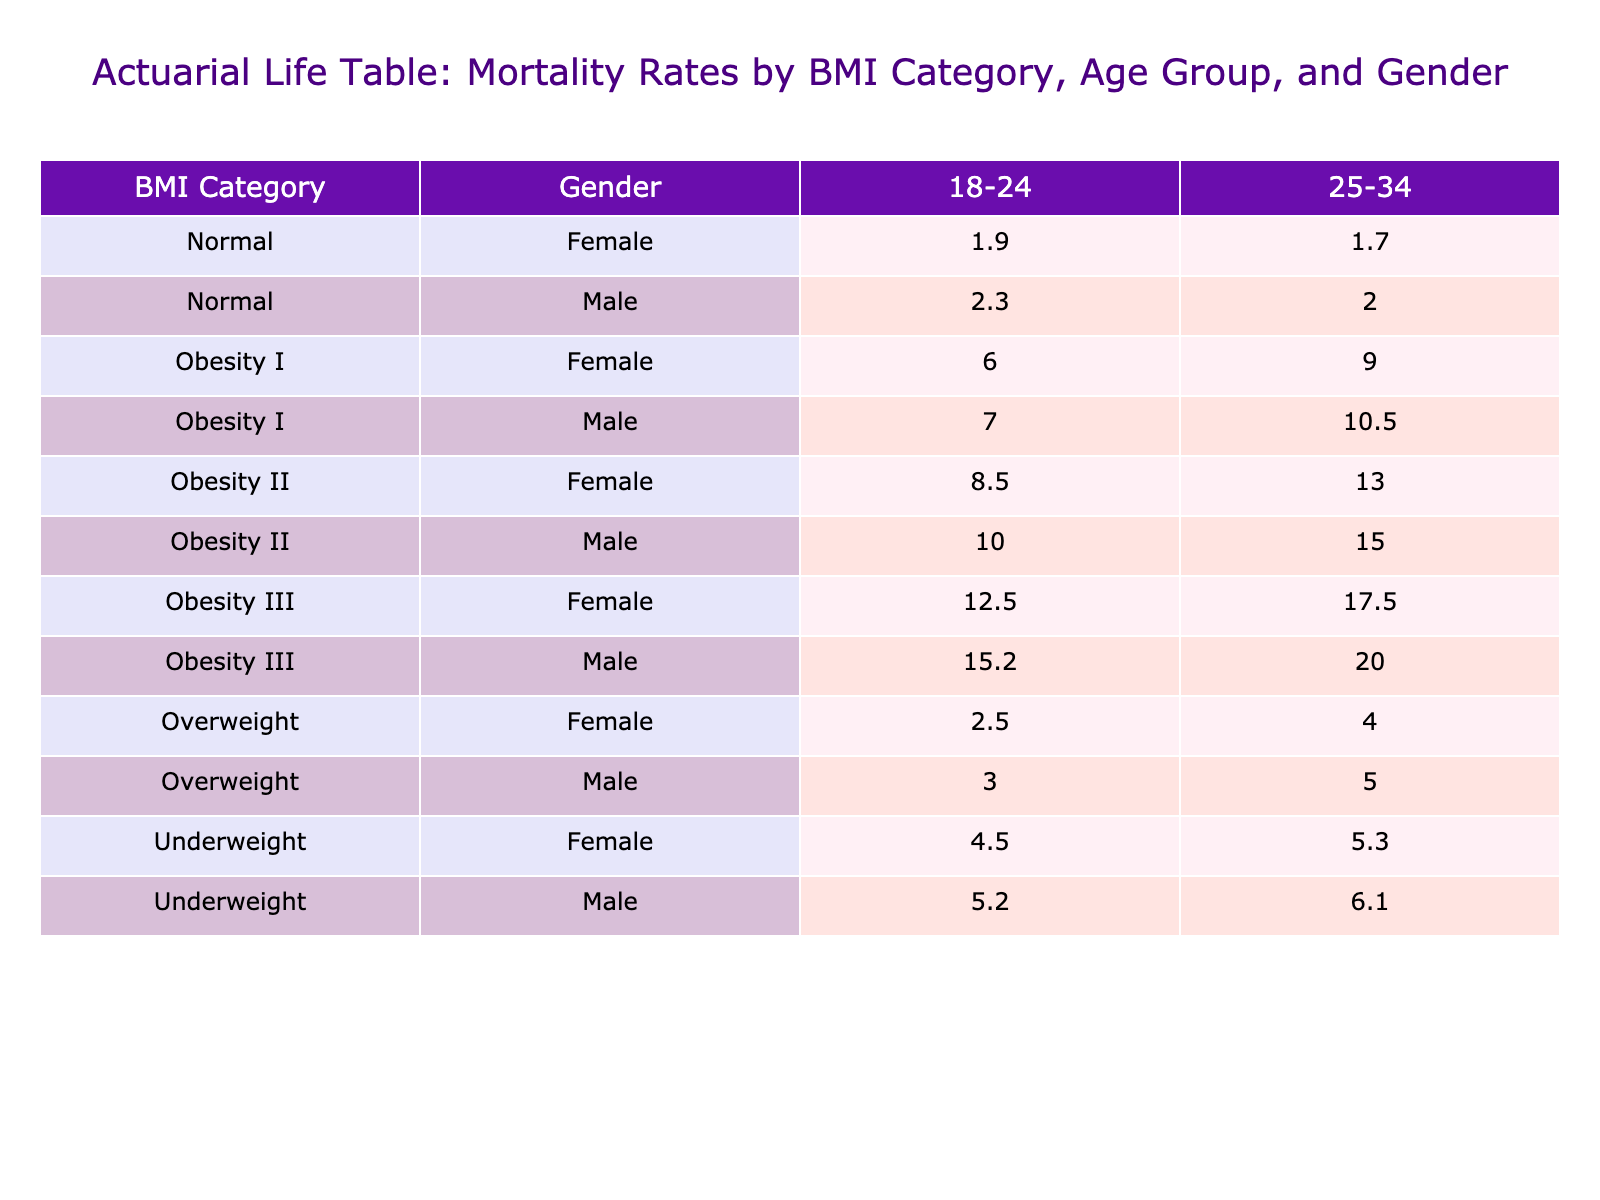What is the mortality rate for overweight females aged 18-24? The table shows that the mortality rate for overweight females in the 18-24 age group is 2.5 per 1000.
Answer: 2.5 Which BMI category has the highest mortality rate for males aged 25-34? By examining the table, obesity III shows the highest mortality rate of 20.0 for males in the 25-34 age group, compared to other categories.
Answer: Obesity III What is the difference in mortality rates between obesity I and obesity II for females aged 25-34? The table indicates that the mortality rate for obesity I females is 9.0 and for obesity II females is 13.0. The difference is calculated as 13.0 - 9.0 = 4.0.
Answer: 4.0 Is the mortality rate for underweight females higher than that for normal-weight females in the age group 25-34? The table lists the underweight females at 5.3 and the normal-weight females at 1.7 for the 25-34 age group. Since 5.3 is greater than 1.7, the statement is true.
Answer: Yes What is the average mortality rate for all categories of males aged 18-24? Summing the mortality rates for males in the 18-24 age group gives: 5.2 (Underweight) + 2.3 (Normal) + 3.0 (Overweight) + 7.0 (Obesity I) + 10.0 (Obesity II) + 15.2 (Obesity III) = 43.7. There are 6 categories, so the average is 43.7 / 6 ≈ 7.28.
Answer: 7.28 What is the highest mortality rate among females aged 18-24 and what BMI category does that belong to? Looking at the table, the highest rate for females aged 18-24 is 12.5 from the obesity III category.
Answer: 12.5 (Obesity III) Are the mortality rates for normal-weight females generally higher than those of underweight females across all age groups? Checking the table, underweight females have rates of 4.5 and 5.3, while normal-weight females have rates of 1.9 and 1.7. Since all values for normal-weight are lower, the answer is no.
Answer: No What is the combined mortality rate for underweight males in both age groups? The mortality rates for underweight males in the age groups 18-24 and 25-34 are 5.2 and 6.1, respectively. The combined rate is 5.2 + 6.1 = 11.3 per 1000.
Answer: 11.3 